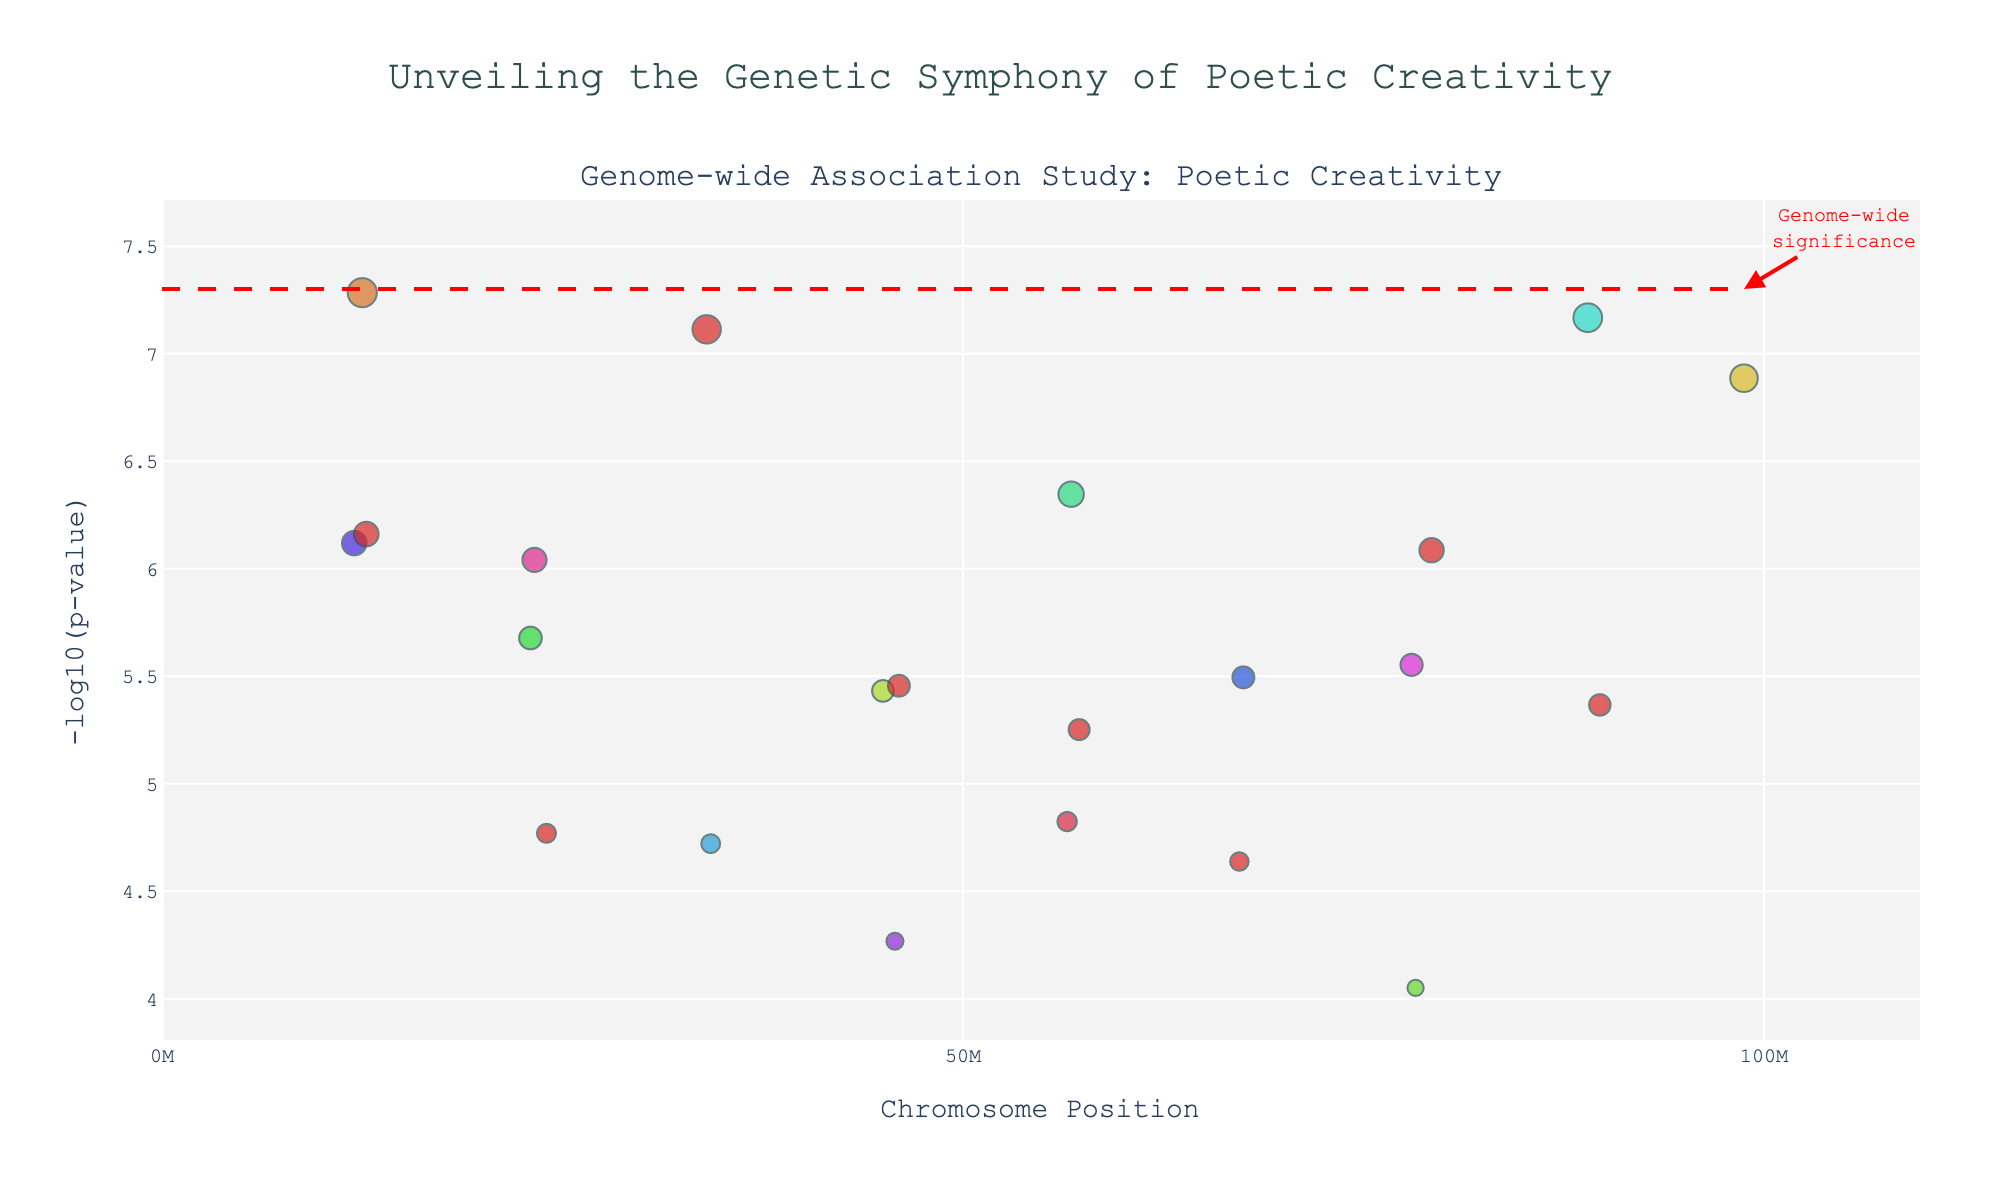What is the title of the plot? The title is usually at the top of the plot and summarises what the plot represents. In this case, it reads "Unveiling the Genetic Symphony of Poetic Creativity".
Answer: Unveiling the Genetic Symphony of Poetic Creativity Which chromosome has the data point with the highest -log10(p-value)? By examining the y-axis (representing -log10(p-value)) and identifying the highest point, we can determine which chromosome it belongs to by looking at its x-axis position.
Answer: Chromosome 1 What is the significance threshold for the Genome-wide significance line? This information is usually drawn as a horizontal line across the plot. The annotation indicates "Genome-wide significance" with a label that marks the threshold value on the y-axis.
Answer: -log10(5e-8) Which gene is identified with the most significant p-value? By identifying the data point with the highest -log10(p-value), we can refer to the associated gene by examining the hover text or tooltip information in the plot.
Answer: FOXP2 Between Chromosomes 2 and 10, which has a gene with a more significant association with poetic creativity? Compare the highest -log10(p-value) data points between Chromosomes 2 and 10. The smaller the p-value, the larger the -log10(p-value).
Answer: Chromosome 2 How many total genetic variants in the plot exceed the genome-wide significance threshold? Count the points that are above the horizontal genome-wide significance line (-log10(5e-8)).
Answer: 3 Is the DRD4 gene significant across all plotted genetic variants? Locate the DRD4 gene data point on Chromosome 4 and compare its -log10(p-value) to the significance threshold line.
Answer: No What is the range of positions on Chromosome 9 displayed in the plot? Identify the minimum and maximum position values for Chromosome 9 and calculate the range.
Answer: 0 to 67500000 List the chromosomes that have multiple data points exceeding a -log10(p-value) of 5. Identify chromosomes with more than one data point that passes the -log10(p-value) of 5 by examining each chromosome's data points.
Answer: 1 and 7 Is there any gene that is significant but not annotated (does not have a label visible)? Check if all significant data points have an associated annotation. Verify by looking if any top points (above the significance line) lack labels.
Answer: No 